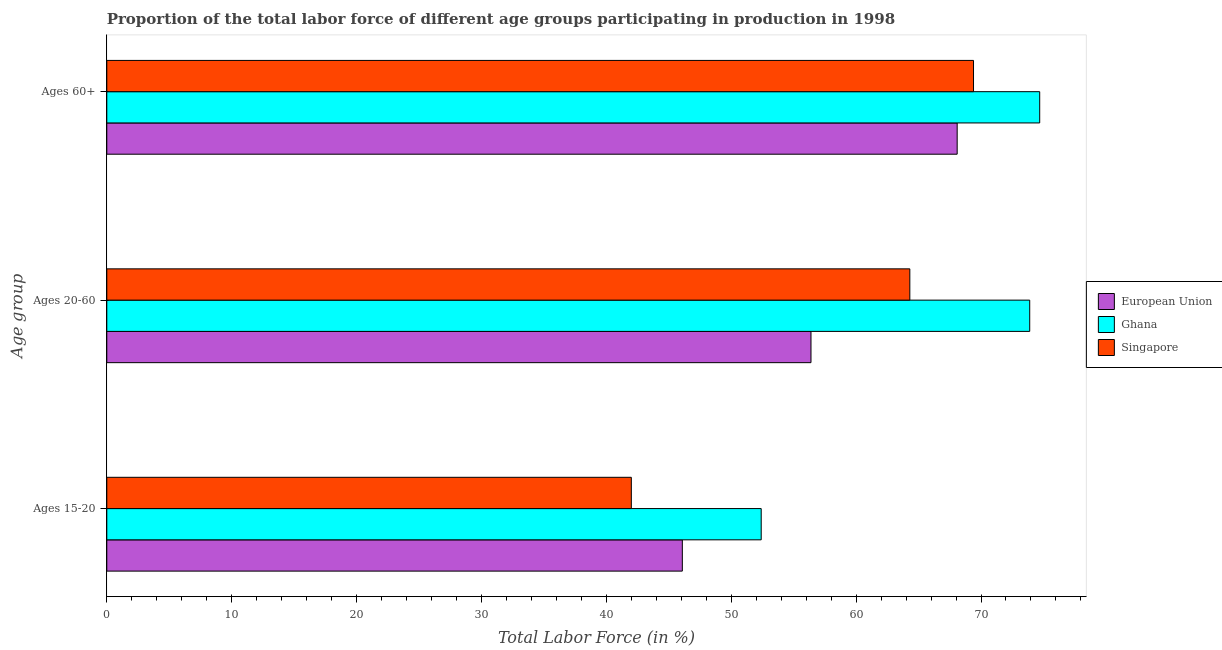How many groups of bars are there?
Offer a very short reply. 3. How many bars are there on the 2nd tick from the top?
Make the answer very short. 3. What is the label of the 1st group of bars from the top?
Provide a short and direct response. Ages 60+. What is the percentage of labor force above age 60 in Ghana?
Offer a very short reply. 74.7. Across all countries, what is the maximum percentage of labor force within the age group 15-20?
Provide a short and direct response. 52.4. Across all countries, what is the minimum percentage of labor force above age 60?
Provide a short and direct response. 68.09. In which country was the percentage of labor force above age 60 maximum?
Make the answer very short. Ghana. In which country was the percentage of labor force within the age group 20-60 minimum?
Your answer should be compact. European Union. What is the total percentage of labor force within the age group 20-60 in the graph?
Offer a very short reply. 194.59. What is the difference between the percentage of labor force above age 60 in Singapore and that in Ghana?
Offer a terse response. -5.3. What is the difference between the percentage of labor force above age 60 in Ghana and the percentage of labor force within the age group 15-20 in Singapore?
Keep it short and to the point. 32.7. What is the average percentage of labor force above age 60 per country?
Provide a succinct answer. 70.73. What is the difference between the percentage of labor force above age 60 and percentage of labor force within the age group 20-60 in Ghana?
Offer a terse response. 0.8. What is the ratio of the percentage of labor force within the age group 15-20 in European Union to that in Ghana?
Your answer should be very brief. 0.88. Is the percentage of labor force within the age group 20-60 in European Union less than that in Ghana?
Give a very brief answer. Yes. Is the difference between the percentage of labor force within the age group 15-20 in European Union and Ghana greater than the difference between the percentage of labor force above age 60 in European Union and Ghana?
Your answer should be compact. Yes. What is the difference between the highest and the second highest percentage of labor force within the age group 15-20?
Provide a succinct answer. 6.32. What is the difference between the highest and the lowest percentage of labor force above age 60?
Give a very brief answer. 6.61. What does the 1st bar from the top in Ages 15-20 represents?
Give a very brief answer. Singapore. What does the 3rd bar from the bottom in Ages 15-20 represents?
Offer a very short reply. Singapore. How many bars are there?
Provide a short and direct response. 9. What is the difference between two consecutive major ticks on the X-axis?
Provide a succinct answer. 10. Are the values on the major ticks of X-axis written in scientific E-notation?
Make the answer very short. No. How many legend labels are there?
Offer a very short reply. 3. What is the title of the graph?
Keep it short and to the point. Proportion of the total labor force of different age groups participating in production in 1998. Does "Guyana" appear as one of the legend labels in the graph?
Keep it short and to the point. No. What is the label or title of the Y-axis?
Offer a terse response. Age group. What is the Total Labor Force (in %) of European Union in Ages 15-20?
Offer a very short reply. 46.08. What is the Total Labor Force (in %) in Ghana in Ages 15-20?
Provide a succinct answer. 52.4. What is the Total Labor Force (in %) of European Union in Ages 20-60?
Your answer should be compact. 56.39. What is the Total Labor Force (in %) of Ghana in Ages 20-60?
Offer a terse response. 73.9. What is the Total Labor Force (in %) in Singapore in Ages 20-60?
Offer a very short reply. 64.3. What is the Total Labor Force (in %) in European Union in Ages 60+?
Provide a succinct answer. 68.09. What is the Total Labor Force (in %) of Ghana in Ages 60+?
Offer a terse response. 74.7. What is the Total Labor Force (in %) of Singapore in Ages 60+?
Provide a short and direct response. 69.4. Across all Age group, what is the maximum Total Labor Force (in %) of European Union?
Ensure brevity in your answer.  68.09. Across all Age group, what is the maximum Total Labor Force (in %) in Ghana?
Your answer should be compact. 74.7. Across all Age group, what is the maximum Total Labor Force (in %) in Singapore?
Offer a very short reply. 69.4. Across all Age group, what is the minimum Total Labor Force (in %) of European Union?
Offer a very short reply. 46.08. Across all Age group, what is the minimum Total Labor Force (in %) in Ghana?
Offer a terse response. 52.4. What is the total Total Labor Force (in %) of European Union in the graph?
Make the answer very short. 170.56. What is the total Total Labor Force (in %) of Ghana in the graph?
Provide a short and direct response. 201. What is the total Total Labor Force (in %) in Singapore in the graph?
Ensure brevity in your answer.  175.7. What is the difference between the Total Labor Force (in %) of European Union in Ages 15-20 and that in Ages 20-60?
Keep it short and to the point. -10.3. What is the difference between the Total Labor Force (in %) in Ghana in Ages 15-20 and that in Ages 20-60?
Provide a succinct answer. -21.5. What is the difference between the Total Labor Force (in %) of Singapore in Ages 15-20 and that in Ages 20-60?
Your answer should be compact. -22.3. What is the difference between the Total Labor Force (in %) of European Union in Ages 15-20 and that in Ages 60+?
Keep it short and to the point. -22.01. What is the difference between the Total Labor Force (in %) of Ghana in Ages 15-20 and that in Ages 60+?
Keep it short and to the point. -22.3. What is the difference between the Total Labor Force (in %) in Singapore in Ages 15-20 and that in Ages 60+?
Your answer should be very brief. -27.4. What is the difference between the Total Labor Force (in %) of European Union in Ages 20-60 and that in Ages 60+?
Your response must be concise. -11.71. What is the difference between the Total Labor Force (in %) in Ghana in Ages 20-60 and that in Ages 60+?
Your response must be concise. -0.8. What is the difference between the Total Labor Force (in %) of Singapore in Ages 20-60 and that in Ages 60+?
Your answer should be compact. -5.1. What is the difference between the Total Labor Force (in %) of European Union in Ages 15-20 and the Total Labor Force (in %) of Ghana in Ages 20-60?
Keep it short and to the point. -27.82. What is the difference between the Total Labor Force (in %) of European Union in Ages 15-20 and the Total Labor Force (in %) of Singapore in Ages 20-60?
Your answer should be compact. -18.22. What is the difference between the Total Labor Force (in %) of Ghana in Ages 15-20 and the Total Labor Force (in %) of Singapore in Ages 20-60?
Your answer should be compact. -11.9. What is the difference between the Total Labor Force (in %) of European Union in Ages 15-20 and the Total Labor Force (in %) of Ghana in Ages 60+?
Your answer should be very brief. -28.62. What is the difference between the Total Labor Force (in %) of European Union in Ages 15-20 and the Total Labor Force (in %) of Singapore in Ages 60+?
Your answer should be very brief. -23.32. What is the difference between the Total Labor Force (in %) in Ghana in Ages 15-20 and the Total Labor Force (in %) in Singapore in Ages 60+?
Offer a terse response. -17. What is the difference between the Total Labor Force (in %) in European Union in Ages 20-60 and the Total Labor Force (in %) in Ghana in Ages 60+?
Keep it short and to the point. -18.31. What is the difference between the Total Labor Force (in %) in European Union in Ages 20-60 and the Total Labor Force (in %) in Singapore in Ages 60+?
Ensure brevity in your answer.  -13.01. What is the average Total Labor Force (in %) of European Union per Age group?
Provide a succinct answer. 56.85. What is the average Total Labor Force (in %) of Ghana per Age group?
Make the answer very short. 67. What is the average Total Labor Force (in %) of Singapore per Age group?
Keep it short and to the point. 58.57. What is the difference between the Total Labor Force (in %) in European Union and Total Labor Force (in %) in Ghana in Ages 15-20?
Offer a terse response. -6.32. What is the difference between the Total Labor Force (in %) of European Union and Total Labor Force (in %) of Singapore in Ages 15-20?
Your answer should be compact. 4.08. What is the difference between the Total Labor Force (in %) in Ghana and Total Labor Force (in %) in Singapore in Ages 15-20?
Give a very brief answer. 10.4. What is the difference between the Total Labor Force (in %) of European Union and Total Labor Force (in %) of Ghana in Ages 20-60?
Offer a very short reply. -17.51. What is the difference between the Total Labor Force (in %) of European Union and Total Labor Force (in %) of Singapore in Ages 20-60?
Provide a short and direct response. -7.91. What is the difference between the Total Labor Force (in %) of Ghana and Total Labor Force (in %) of Singapore in Ages 20-60?
Offer a terse response. 9.6. What is the difference between the Total Labor Force (in %) of European Union and Total Labor Force (in %) of Ghana in Ages 60+?
Give a very brief answer. -6.61. What is the difference between the Total Labor Force (in %) in European Union and Total Labor Force (in %) in Singapore in Ages 60+?
Offer a terse response. -1.31. What is the ratio of the Total Labor Force (in %) in European Union in Ages 15-20 to that in Ages 20-60?
Provide a short and direct response. 0.82. What is the ratio of the Total Labor Force (in %) of Ghana in Ages 15-20 to that in Ages 20-60?
Offer a terse response. 0.71. What is the ratio of the Total Labor Force (in %) in Singapore in Ages 15-20 to that in Ages 20-60?
Ensure brevity in your answer.  0.65. What is the ratio of the Total Labor Force (in %) in European Union in Ages 15-20 to that in Ages 60+?
Provide a short and direct response. 0.68. What is the ratio of the Total Labor Force (in %) of Ghana in Ages 15-20 to that in Ages 60+?
Offer a terse response. 0.7. What is the ratio of the Total Labor Force (in %) in Singapore in Ages 15-20 to that in Ages 60+?
Give a very brief answer. 0.61. What is the ratio of the Total Labor Force (in %) of European Union in Ages 20-60 to that in Ages 60+?
Give a very brief answer. 0.83. What is the ratio of the Total Labor Force (in %) of Ghana in Ages 20-60 to that in Ages 60+?
Give a very brief answer. 0.99. What is the ratio of the Total Labor Force (in %) of Singapore in Ages 20-60 to that in Ages 60+?
Give a very brief answer. 0.93. What is the difference between the highest and the second highest Total Labor Force (in %) of European Union?
Ensure brevity in your answer.  11.71. What is the difference between the highest and the second highest Total Labor Force (in %) in Ghana?
Offer a very short reply. 0.8. What is the difference between the highest and the second highest Total Labor Force (in %) in Singapore?
Your response must be concise. 5.1. What is the difference between the highest and the lowest Total Labor Force (in %) of European Union?
Ensure brevity in your answer.  22.01. What is the difference between the highest and the lowest Total Labor Force (in %) of Ghana?
Your answer should be compact. 22.3. What is the difference between the highest and the lowest Total Labor Force (in %) of Singapore?
Make the answer very short. 27.4. 